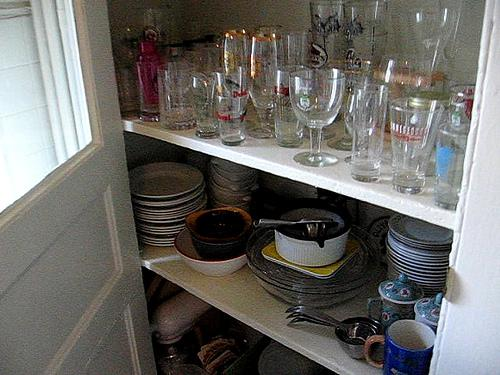Question: where was this photo taken?
Choices:
A. At the park.
B. Kitchen cabinet.
C. At the bank.
D. At the store.
Answer with the letter. Answer: B Question: what color are the top shelf glasses?
Choices:
A. Blue.
B. Green.
C. Red.
D. Clear.
Answer with the letter. Answer: D Question: how many shelves are seen?
Choices:
A. Four.
B. Five.
C. None.
D. Three.
Answer with the letter. Answer: D Question: who is standing next to the cabinet?
Choices:
A. A ghost.
B. A man.
C. A woman.
D. No one.
Answer with the letter. Answer: D Question: what color is the cabinet?
Choices:
A. Silver.
B. White.
C. Brown.
D. Black.
Answer with the letter. Answer: B 